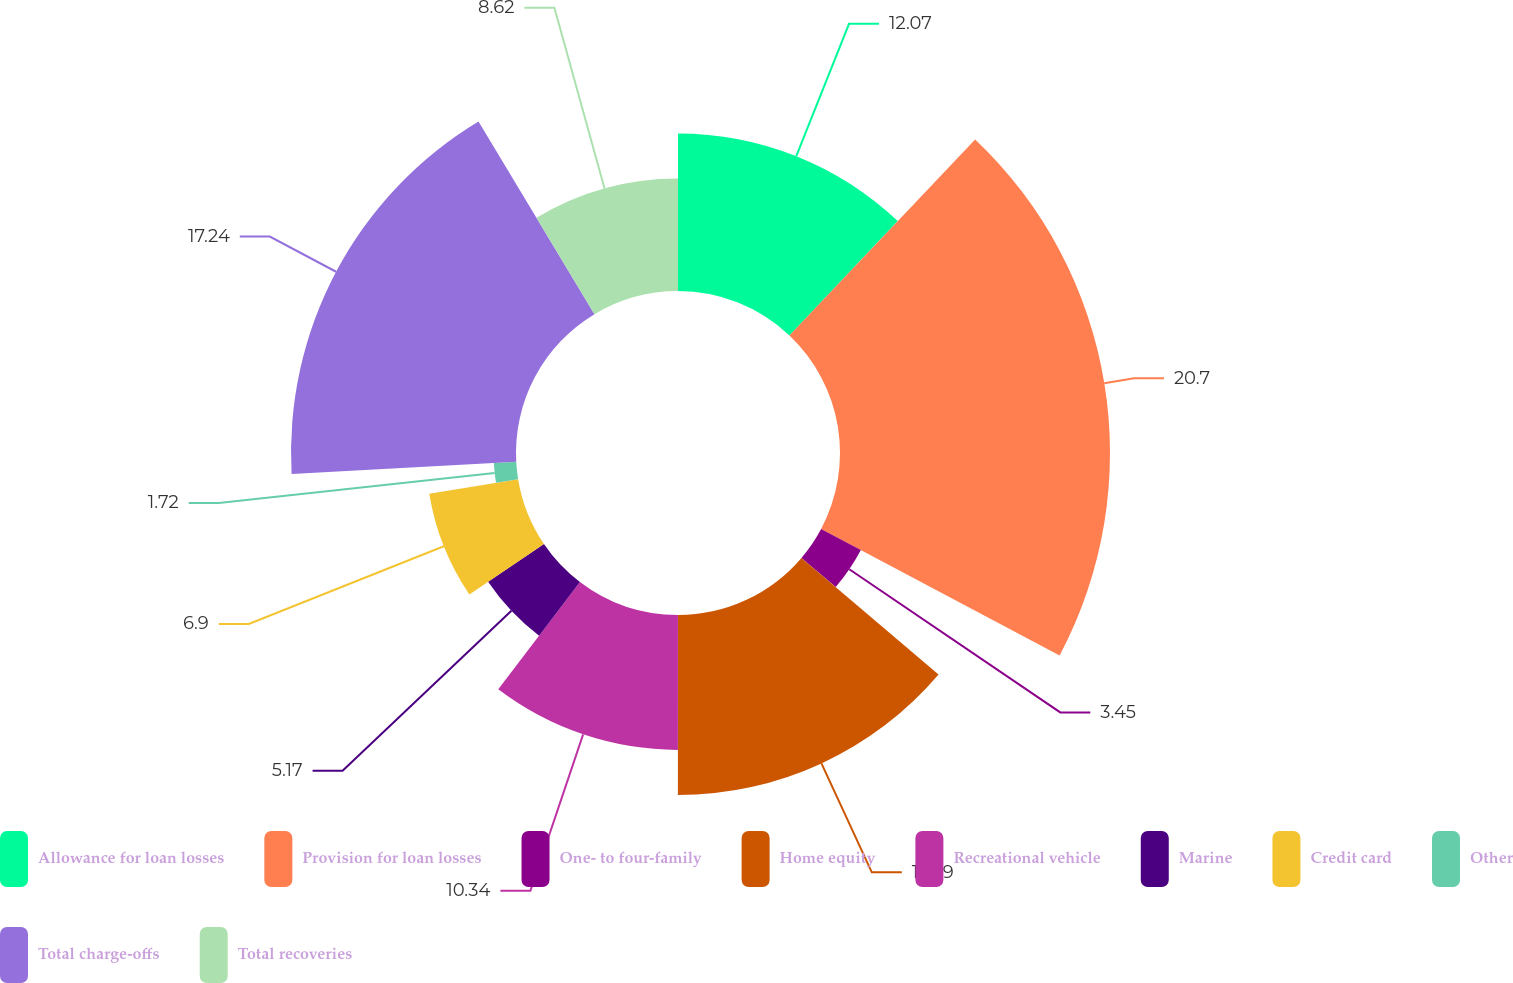<chart> <loc_0><loc_0><loc_500><loc_500><pie_chart><fcel>Allowance for loan losses<fcel>Provision for loan losses<fcel>One- to four-family<fcel>Home equity<fcel>Recreational vehicle<fcel>Marine<fcel>Credit card<fcel>Other<fcel>Total charge-offs<fcel>Total recoveries<nl><fcel>12.07%<fcel>20.69%<fcel>3.45%<fcel>13.79%<fcel>10.34%<fcel>5.17%<fcel>6.9%<fcel>1.72%<fcel>17.24%<fcel>8.62%<nl></chart> 